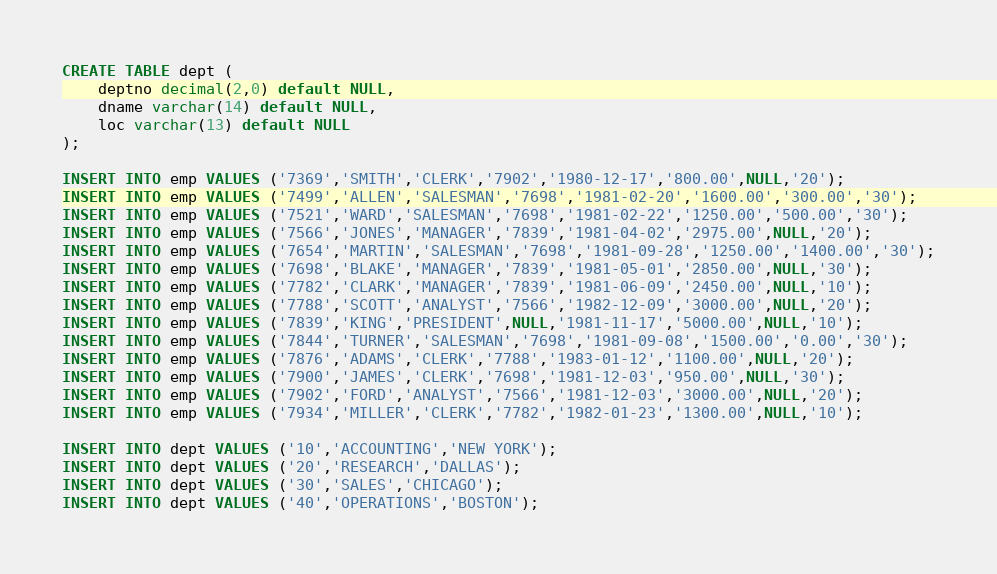Convert code to text. <code><loc_0><loc_0><loc_500><loc_500><_SQL_>
CREATE TABLE dept (
	deptno decimal(2,0) default NULL,
	dname varchar(14) default NULL,
	loc varchar(13) default NULL
);

INSERT INTO emp VALUES ('7369','SMITH','CLERK','7902','1980-12-17','800.00',NULL,'20');
INSERT INTO emp VALUES ('7499','ALLEN','SALESMAN','7698','1981-02-20','1600.00','300.00','30');
INSERT INTO emp VALUES ('7521','WARD','SALESMAN','7698','1981-02-22','1250.00','500.00','30');
INSERT INTO emp VALUES ('7566','JONES','MANAGER','7839','1981-04-02','2975.00',NULL,'20');
INSERT INTO emp VALUES ('7654','MARTIN','SALESMAN','7698','1981-09-28','1250.00','1400.00','30');
INSERT INTO emp VALUES ('7698','BLAKE','MANAGER','7839','1981-05-01','2850.00',NULL,'30');
INSERT INTO emp VALUES ('7782','CLARK','MANAGER','7839','1981-06-09','2450.00',NULL,'10');
INSERT INTO emp VALUES ('7788','SCOTT','ANALYST','7566','1982-12-09','3000.00',NULL,'20');
INSERT INTO emp VALUES ('7839','KING','PRESIDENT',NULL,'1981-11-17','5000.00',NULL,'10');
INSERT INTO emp VALUES ('7844','TURNER','SALESMAN','7698','1981-09-08','1500.00','0.00','30');
INSERT INTO emp VALUES ('7876','ADAMS','CLERK','7788','1983-01-12','1100.00',NULL,'20');
INSERT INTO emp VALUES ('7900','JAMES','CLERK','7698','1981-12-03','950.00',NULL,'30');
INSERT INTO emp VALUES ('7902','FORD','ANALYST','7566','1981-12-03','3000.00',NULL,'20');
INSERT INTO emp VALUES ('7934','MILLER','CLERK','7782','1982-01-23','1300.00',NULL,'10');

INSERT INTO dept VALUES ('10','ACCOUNTING','NEW YORK');
INSERT INTO dept VALUES ('20','RESEARCH','DALLAS');
INSERT INTO dept VALUES ('30','SALES','CHICAGO');
INSERT INTO dept VALUES ('40','OPERATIONS','BOSTON');</code> 